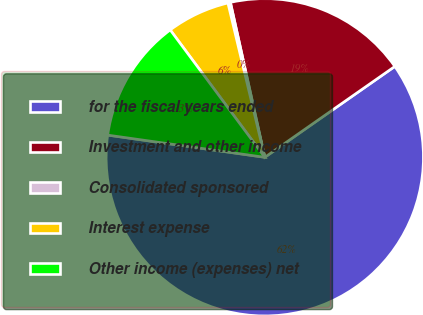Convert chart to OTSL. <chart><loc_0><loc_0><loc_500><loc_500><pie_chart><fcel>for the fiscal years ended<fcel>Investment and other income<fcel>Consolidated sponsored<fcel>Interest expense<fcel>Other income (expenses) net<nl><fcel>61.94%<fcel>18.77%<fcel>0.26%<fcel>6.43%<fcel>12.6%<nl></chart> 